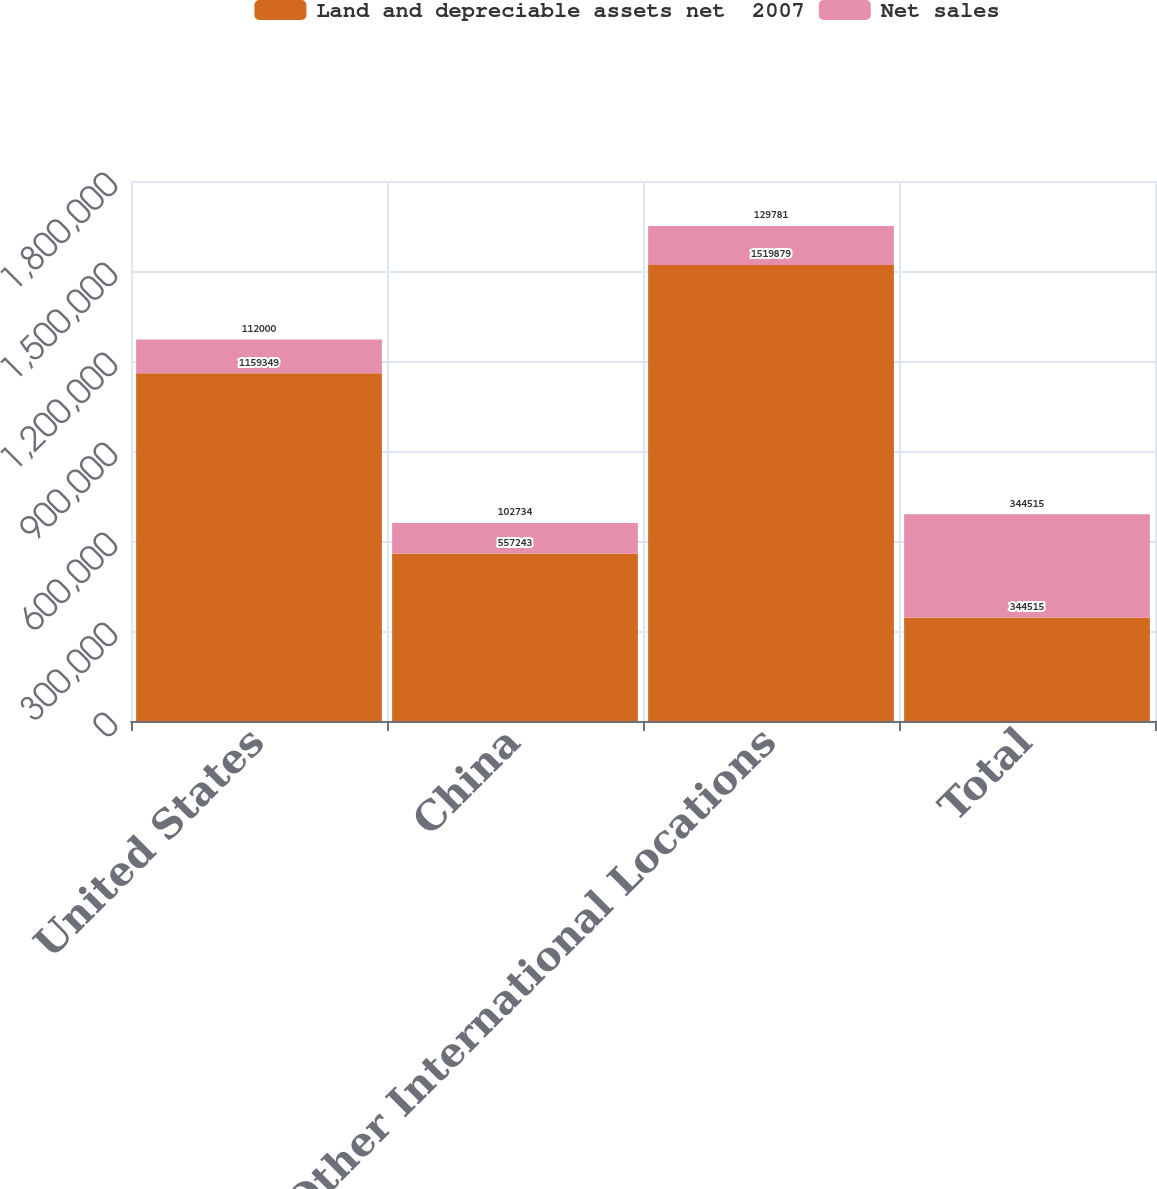Convert chart to OTSL. <chart><loc_0><loc_0><loc_500><loc_500><stacked_bar_chart><ecel><fcel>United States<fcel>China<fcel>Other International Locations<fcel>Total<nl><fcel>Land and depreciable assets net  2007<fcel>1.15935e+06<fcel>557243<fcel>1.51988e+06<fcel>344515<nl><fcel>Net sales<fcel>112000<fcel>102734<fcel>129781<fcel>344515<nl></chart> 